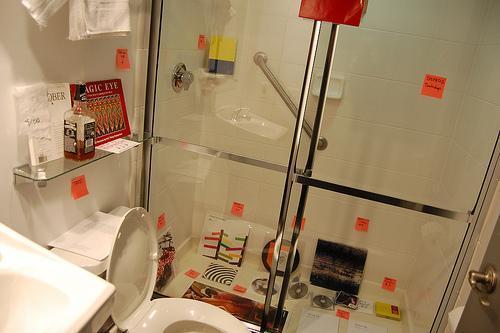How many toilets are there?
Give a very brief answer. 1. 